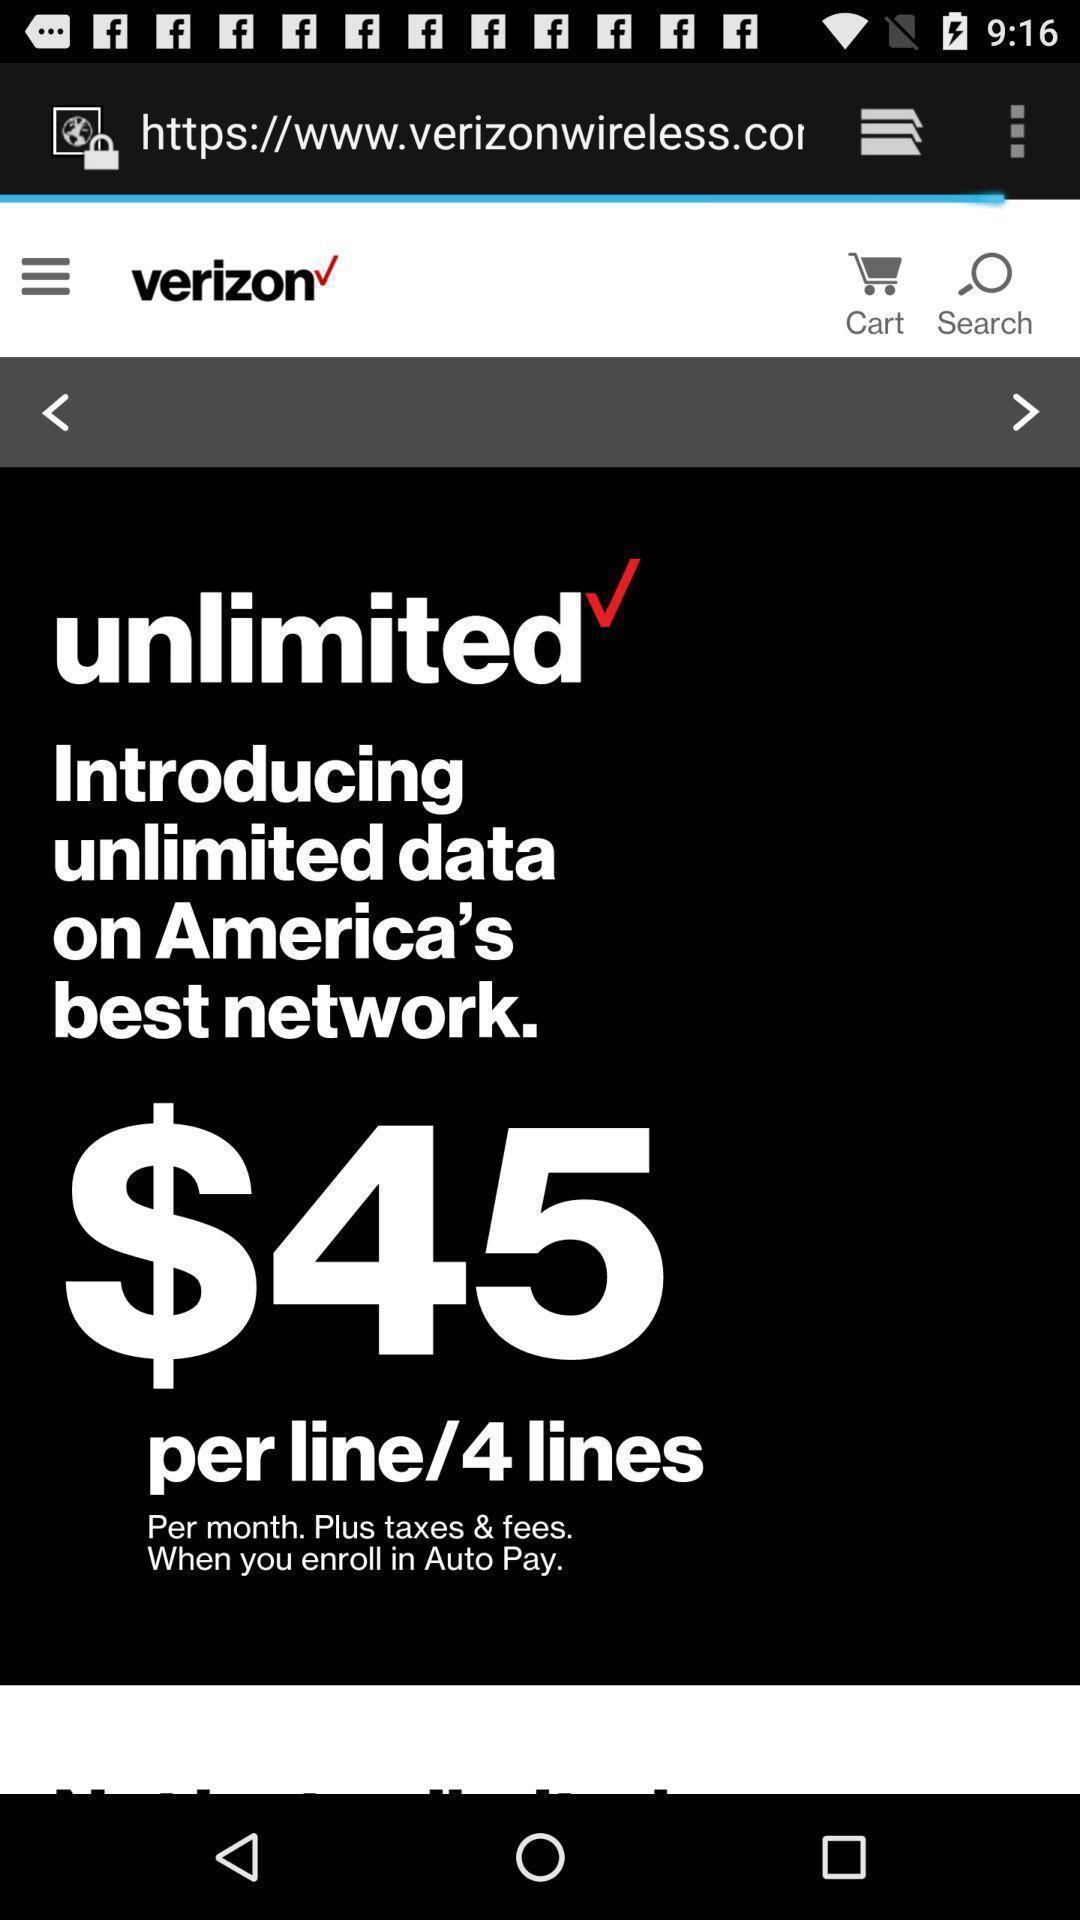Summarize the information in this screenshot. Unlimited data in a verzion. 